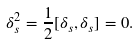<formula> <loc_0><loc_0><loc_500><loc_500>\delta _ { s } ^ { 2 } = \frac { 1 } { 2 } [ \delta _ { s } , \delta _ { s } ] = 0 .</formula> 